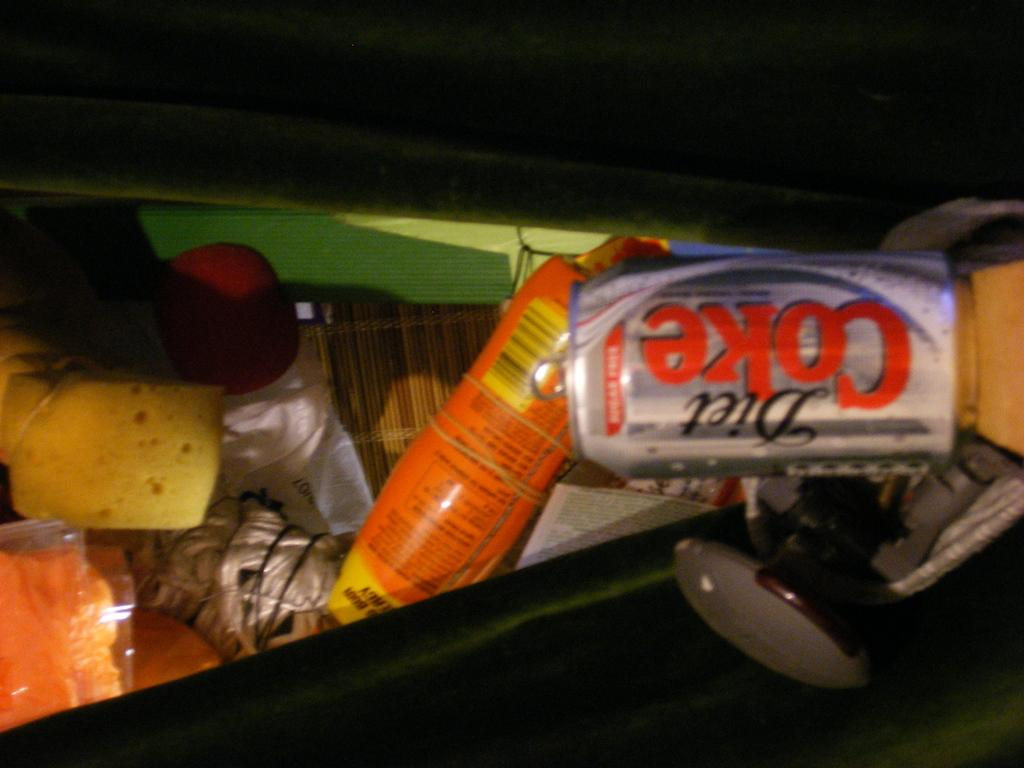What type of container is present in the image? There is a bottle and a can in the image. What other items can be seen in the image? There are other items visible in the image, but their specific details are not mentioned in the provided facts. What is the color of the background in the image? The background of the image is dark. How many tongues can be seen in the image? There are no tongues present in the image. What type of rod is used by the team in the image? There is no team or rod present in the image. 